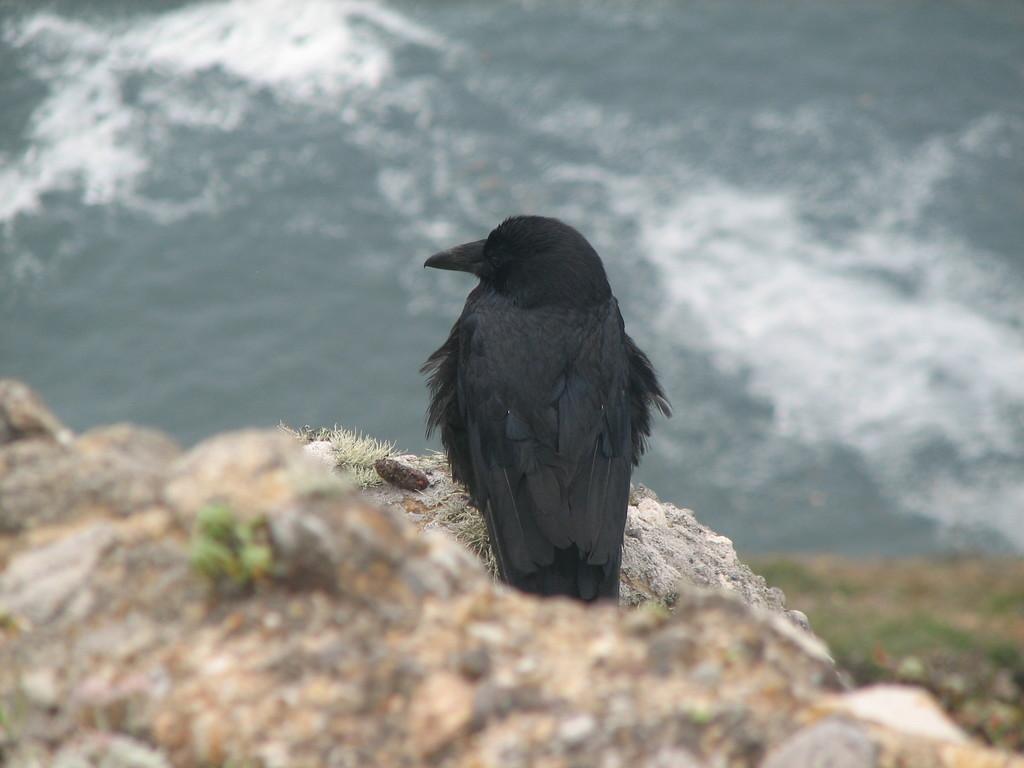Could you give a brief overview of what you see in this image? This picture is clicked outside the city. In the foreground we can see the rock and there is a black color bird seems to be the crow standing on the rock. In the background we can see some objects. 